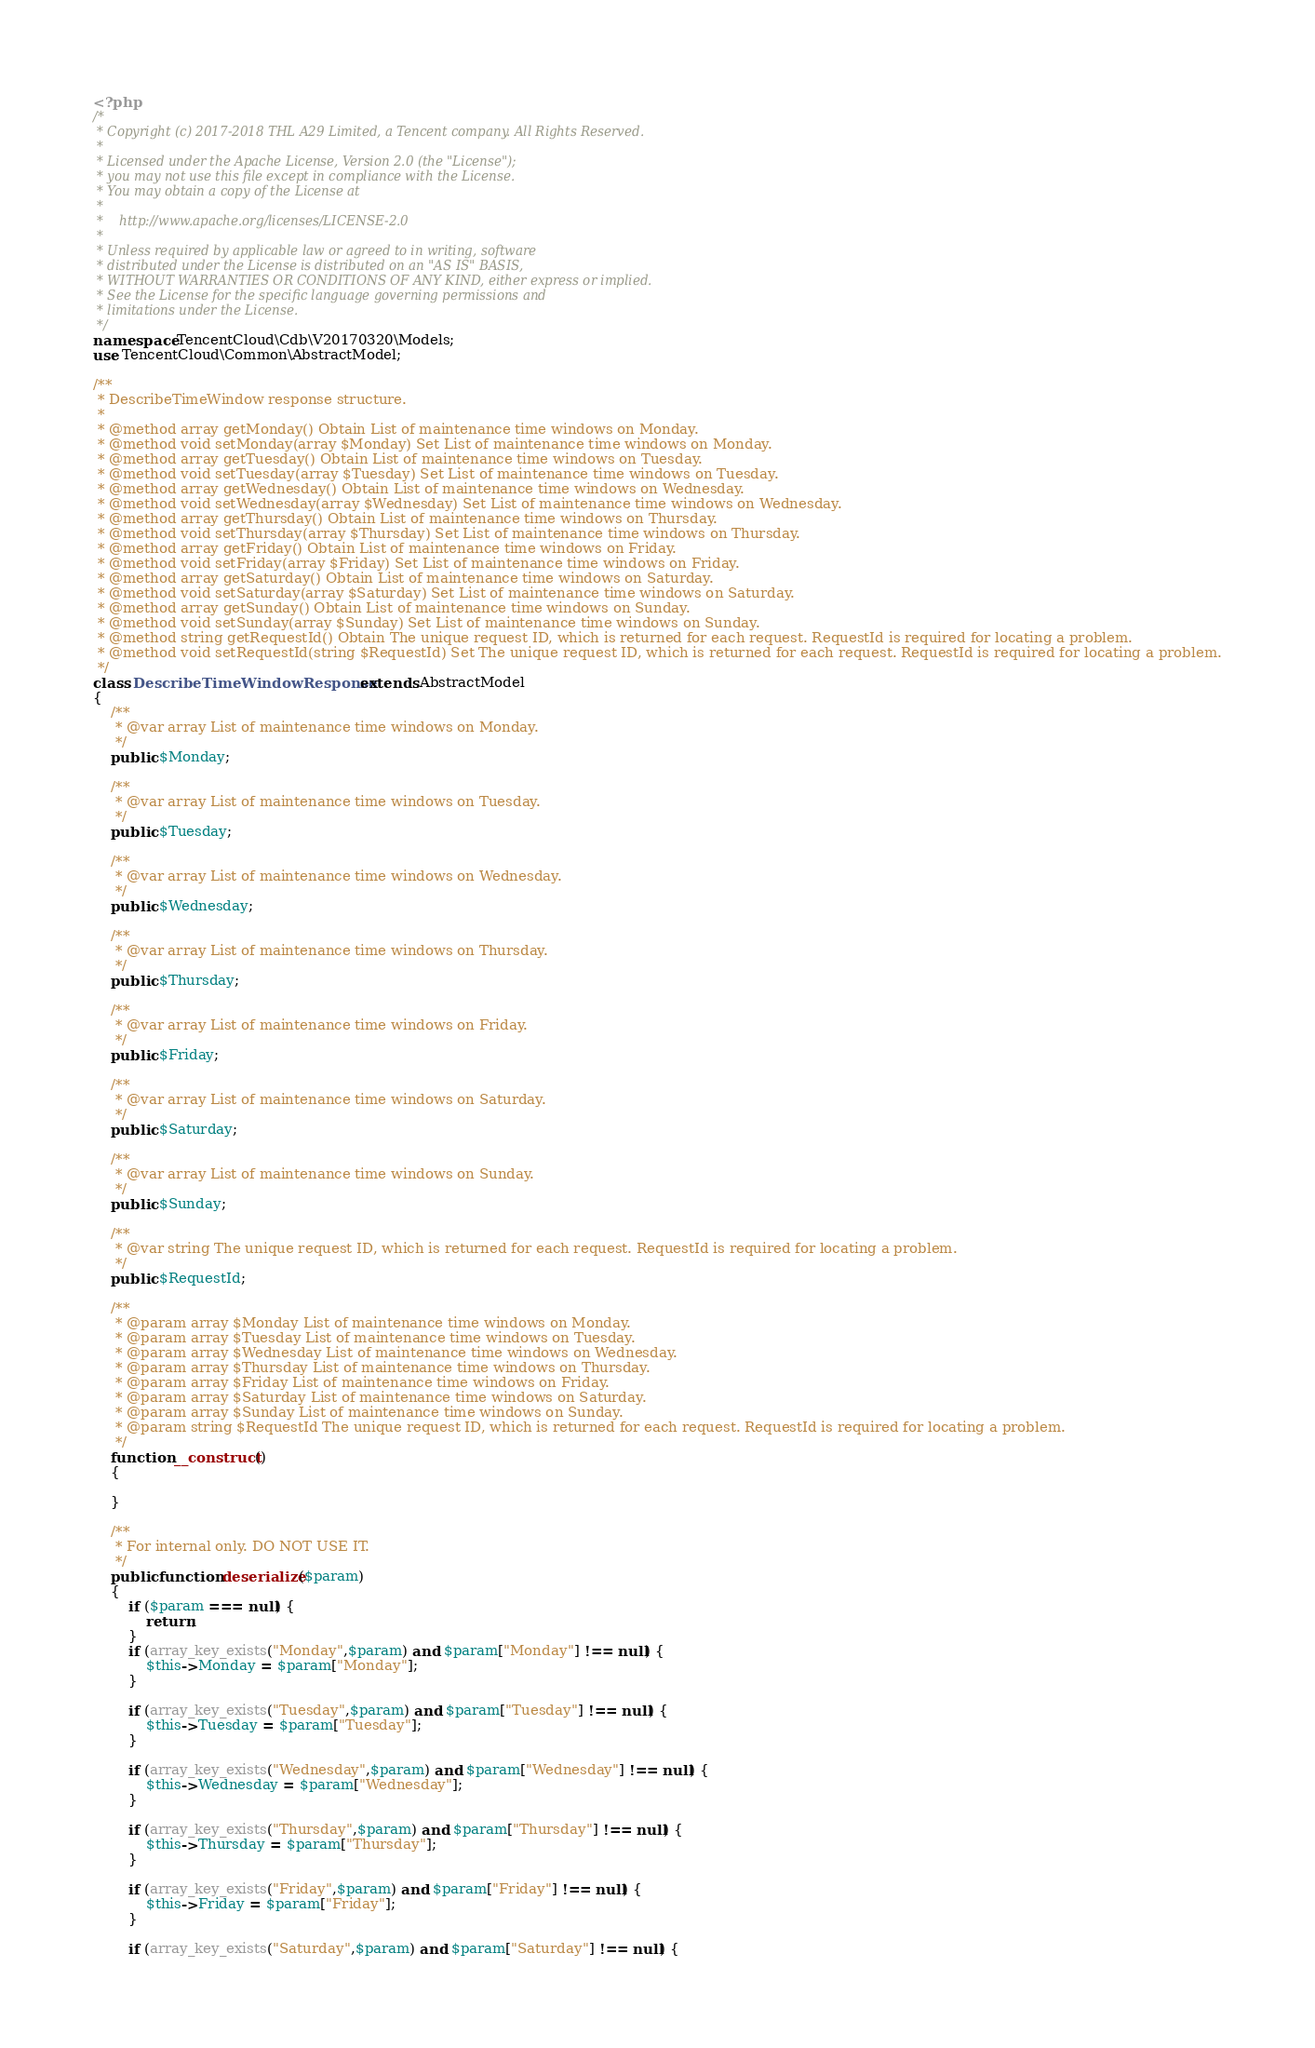Convert code to text. <code><loc_0><loc_0><loc_500><loc_500><_PHP_><?php
/*
 * Copyright (c) 2017-2018 THL A29 Limited, a Tencent company. All Rights Reserved.
 *
 * Licensed under the Apache License, Version 2.0 (the "License");
 * you may not use this file except in compliance with the License.
 * You may obtain a copy of the License at
 *
 *    http://www.apache.org/licenses/LICENSE-2.0
 *
 * Unless required by applicable law or agreed to in writing, software
 * distributed under the License is distributed on an "AS IS" BASIS,
 * WITHOUT WARRANTIES OR CONDITIONS OF ANY KIND, either express or implied.
 * See the License for the specific language governing permissions and
 * limitations under the License.
 */
namespace TencentCloud\Cdb\V20170320\Models;
use TencentCloud\Common\AbstractModel;

/**
 * DescribeTimeWindow response structure.
 *
 * @method array getMonday() Obtain List of maintenance time windows on Monday.
 * @method void setMonday(array $Monday) Set List of maintenance time windows on Monday.
 * @method array getTuesday() Obtain List of maintenance time windows on Tuesday.
 * @method void setTuesday(array $Tuesday) Set List of maintenance time windows on Tuesday.
 * @method array getWednesday() Obtain List of maintenance time windows on Wednesday.
 * @method void setWednesday(array $Wednesday) Set List of maintenance time windows on Wednesday.
 * @method array getThursday() Obtain List of maintenance time windows on Thursday.
 * @method void setThursday(array $Thursday) Set List of maintenance time windows on Thursday.
 * @method array getFriday() Obtain List of maintenance time windows on Friday.
 * @method void setFriday(array $Friday) Set List of maintenance time windows on Friday.
 * @method array getSaturday() Obtain List of maintenance time windows on Saturday.
 * @method void setSaturday(array $Saturday) Set List of maintenance time windows on Saturday.
 * @method array getSunday() Obtain List of maintenance time windows on Sunday.
 * @method void setSunday(array $Sunday) Set List of maintenance time windows on Sunday.
 * @method string getRequestId() Obtain The unique request ID, which is returned for each request. RequestId is required for locating a problem.
 * @method void setRequestId(string $RequestId) Set The unique request ID, which is returned for each request. RequestId is required for locating a problem.
 */
class DescribeTimeWindowResponse extends AbstractModel
{
    /**
     * @var array List of maintenance time windows on Monday.
     */
    public $Monday;

    /**
     * @var array List of maintenance time windows on Tuesday.
     */
    public $Tuesday;

    /**
     * @var array List of maintenance time windows on Wednesday.
     */
    public $Wednesday;

    /**
     * @var array List of maintenance time windows on Thursday.
     */
    public $Thursday;

    /**
     * @var array List of maintenance time windows on Friday.
     */
    public $Friday;

    /**
     * @var array List of maintenance time windows on Saturday.
     */
    public $Saturday;

    /**
     * @var array List of maintenance time windows on Sunday.
     */
    public $Sunday;

    /**
     * @var string The unique request ID, which is returned for each request. RequestId is required for locating a problem.
     */
    public $RequestId;

    /**
     * @param array $Monday List of maintenance time windows on Monday.
     * @param array $Tuesday List of maintenance time windows on Tuesday.
     * @param array $Wednesday List of maintenance time windows on Wednesday.
     * @param array $Thursday List of maintenance time windows on Thursday.
     * @param array $Friday List of maintenance time windows on Friday.
     * @param array $Saturday List of maintenance time windows on Saturday.
     * @param array $Sunday List of maintenance time windows on Sunday.
     * @param string $RequestId The unique request ID, which is returned for each request. RequestId is required for locating a problem.
     */
    function __construct()
    {

    }

    /**
     * For internal only. DO NOT USE IT.
     */
    public function deserialize($param)
    {
        if ($param === null) {
            return;
        }
        if (array_key_exists("Monday",$param) and $param["Monday"] !== null) {
            $this->Monday = $param["Monday"];
        }

        if (array_key_exists("Tuesday",$param) and $param["Tuesday"] !== null) {
            $this->Tuesday = $param["Tuesday"];
        }

        if (array_key_exists("Wednesday",$param) and $param["Wednesday"] !== null) {
            $this->Wednesday = $param["Wednesday"];
        }

        if (array_key_exists("Thursday",$param) and $param["Thursday"] !== null) {
            $this->Thursday = $param["Thursday"];
        }

        if (array_key_exists("Friday",$param) and $param["Friday"] !== null) {
            $this->Friday = $param["Friday"];
        }

        if (array_key_exists("Saturday",$param) and $param["Saturday"] !== null) {</code> 